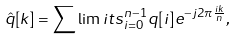<formula> <loc_0><loc_0><loc_500><loc_500>{ \hat { q } } [ k ] = \sum \lim i t s _ { i = 0 } ^ { n - 1 } { q } [ i ] e ^ { - j 2 \pi \frac { i k } { n } } ,</formula> 